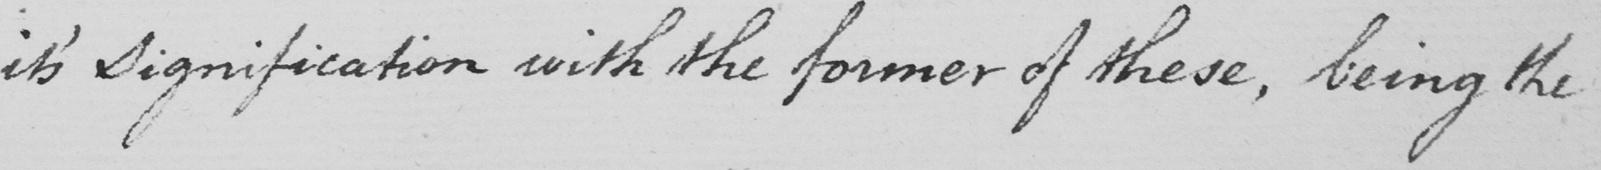Transcribe the text shown in this historical manuscript line. it ' s Signification with the former of these , being the 